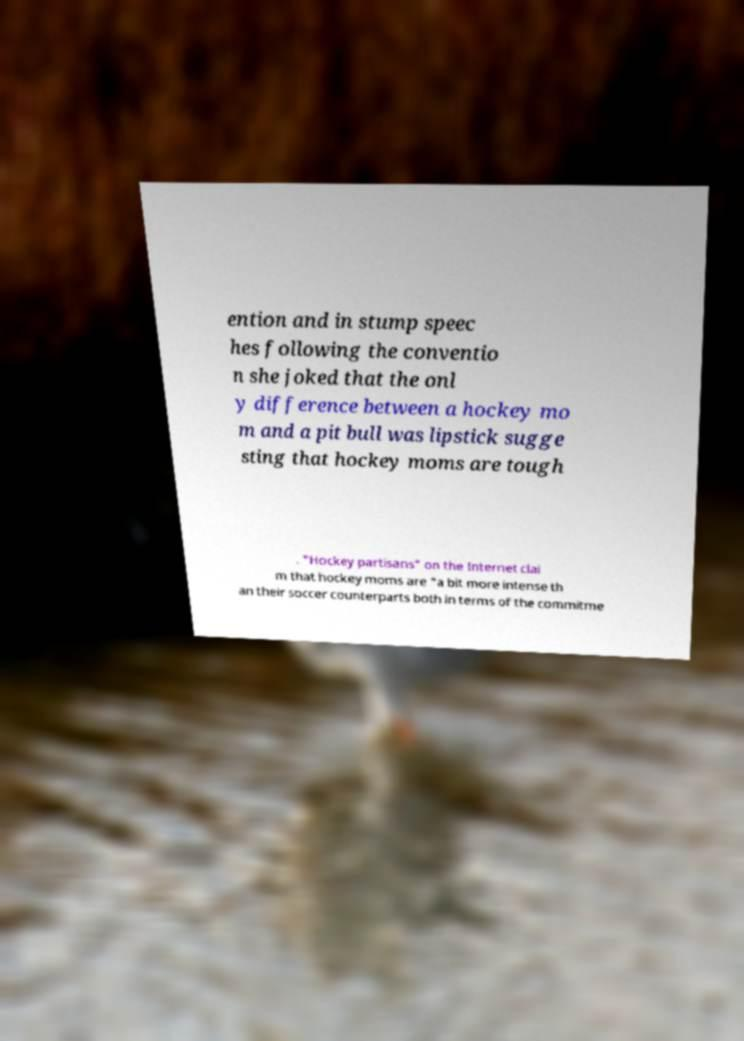Could you extract and type out the text from this image? ention and in stump speec hes following the conventio n she joked that the onl y difference between a hockey mo m and a pit bull was lipstick sugge sting that hockey moms are tough . "Hockey partisans" on the Internet clai m that hockey moms are "a bit more intense th an their soccer counterparts both in terms of the commitme 